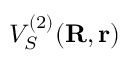Convert formula to latex. <formula><loc_0><loc_0><loc_500><loc_500>V _ { S } ^ { ( 2 ) } ( { R , r } )</formula> 